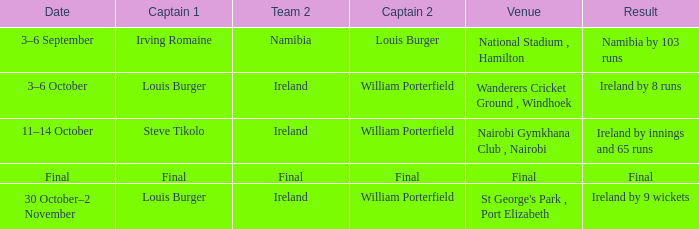Which Result has a Captain 2 of louis burger? Namibia by 103 runs. 